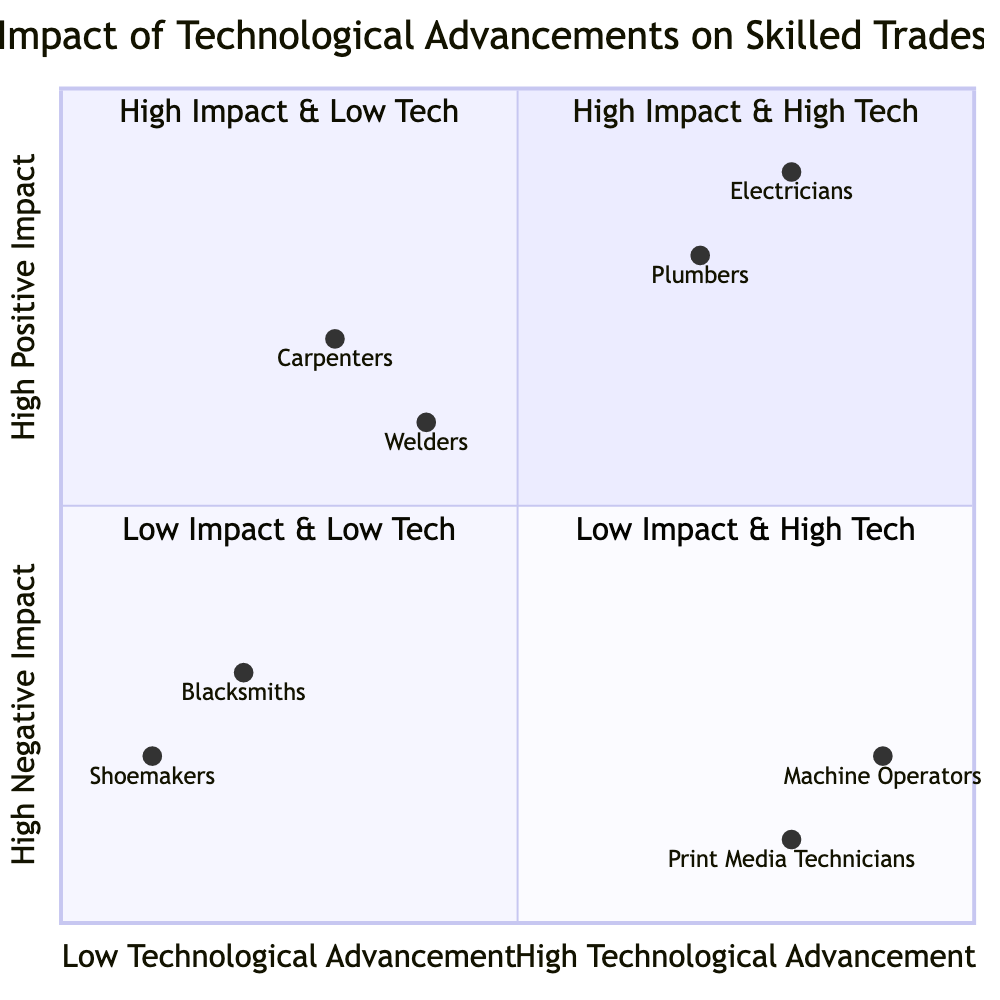What skilled trade has the highest technological advancement? The diagram shows "Electricians" and "Machine Operators" as the trades in the quadrant with high technological advancement, but "Electricians" is the only one in the "High Positive Impact & High Technological Advancement" quadrant.
Answer: Electricians Which skilled trade is associated with automated leak detection systems? According to the diagram, "Plumbers" are associated with automated leak detection systems, which is listed in the quadrant with high positive impact and high technological advancement.
Answer: Plumbers How many skilled trades are in the "High Negative Impact & High Technological Advancement" quadrant? There are two skilled trades in this quadrant: "Machine Operators" and "Print Media Technicians." This can be counted directly from the quadrant's entries.
Answer: 2 Which skilled trade experiences a decline due to digital printing technologies? The chart indicates that "Print Media Technicians" are negatively impacted due to technological advancements in digital printing, which leads to job displacement.
Answer: Print Media Technicians In the "High Positive Impact & Low Technological Advancement" quadrant, what is the impact description for welders? The description for welders states that "higher quality welds and increased safety, although core skills remain relatively unchanged," which can be found in the relevant section of the diagram.
Answer: Higher quality welds and increased safety Which two skilled trades have low technological advancement and high negative impact? The diagram details "Blacksmiths" and "Shoemakers" as the skilled trades placed in the low technological advancement and high negative impact quadrant. This can be directly observed from their placements.
Answer: Blacksmiths and Shoemakers What is the impact description for the skilled trade with smart home technology? The description for "Electricians," related to smart home technology, states an "increased demand for installation and maintenance of smart home systems, leading to higher job opportunities and specialized skills." This can be identified in the impact description.
Answer: Increased demand for installation and maintenance of smart home systems How does the impact of automation on machine operators differ from that of plumbers? Machine operators face potential job reductions due to automation, while plumbers benefit from automated leak detection with enhanced efficiency and job opportunities. This reflects a contrast between negative and positive impacts due to technological advancements, as seen in the respective quadrants.
Answer: Negative impact vs. Positive impact What degree of technological advancement do blacksmiths have? The diagram categorizes "Blacksmiths" in the low technological advancement area with basic power hammers, which indicates a lack of significant technological integration.
Answer: Low 